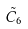Convert formula to latex. <formula><loc_0><loc_0><loc_500><loc_500>\tilde { C } _ { 6 }</formula> 